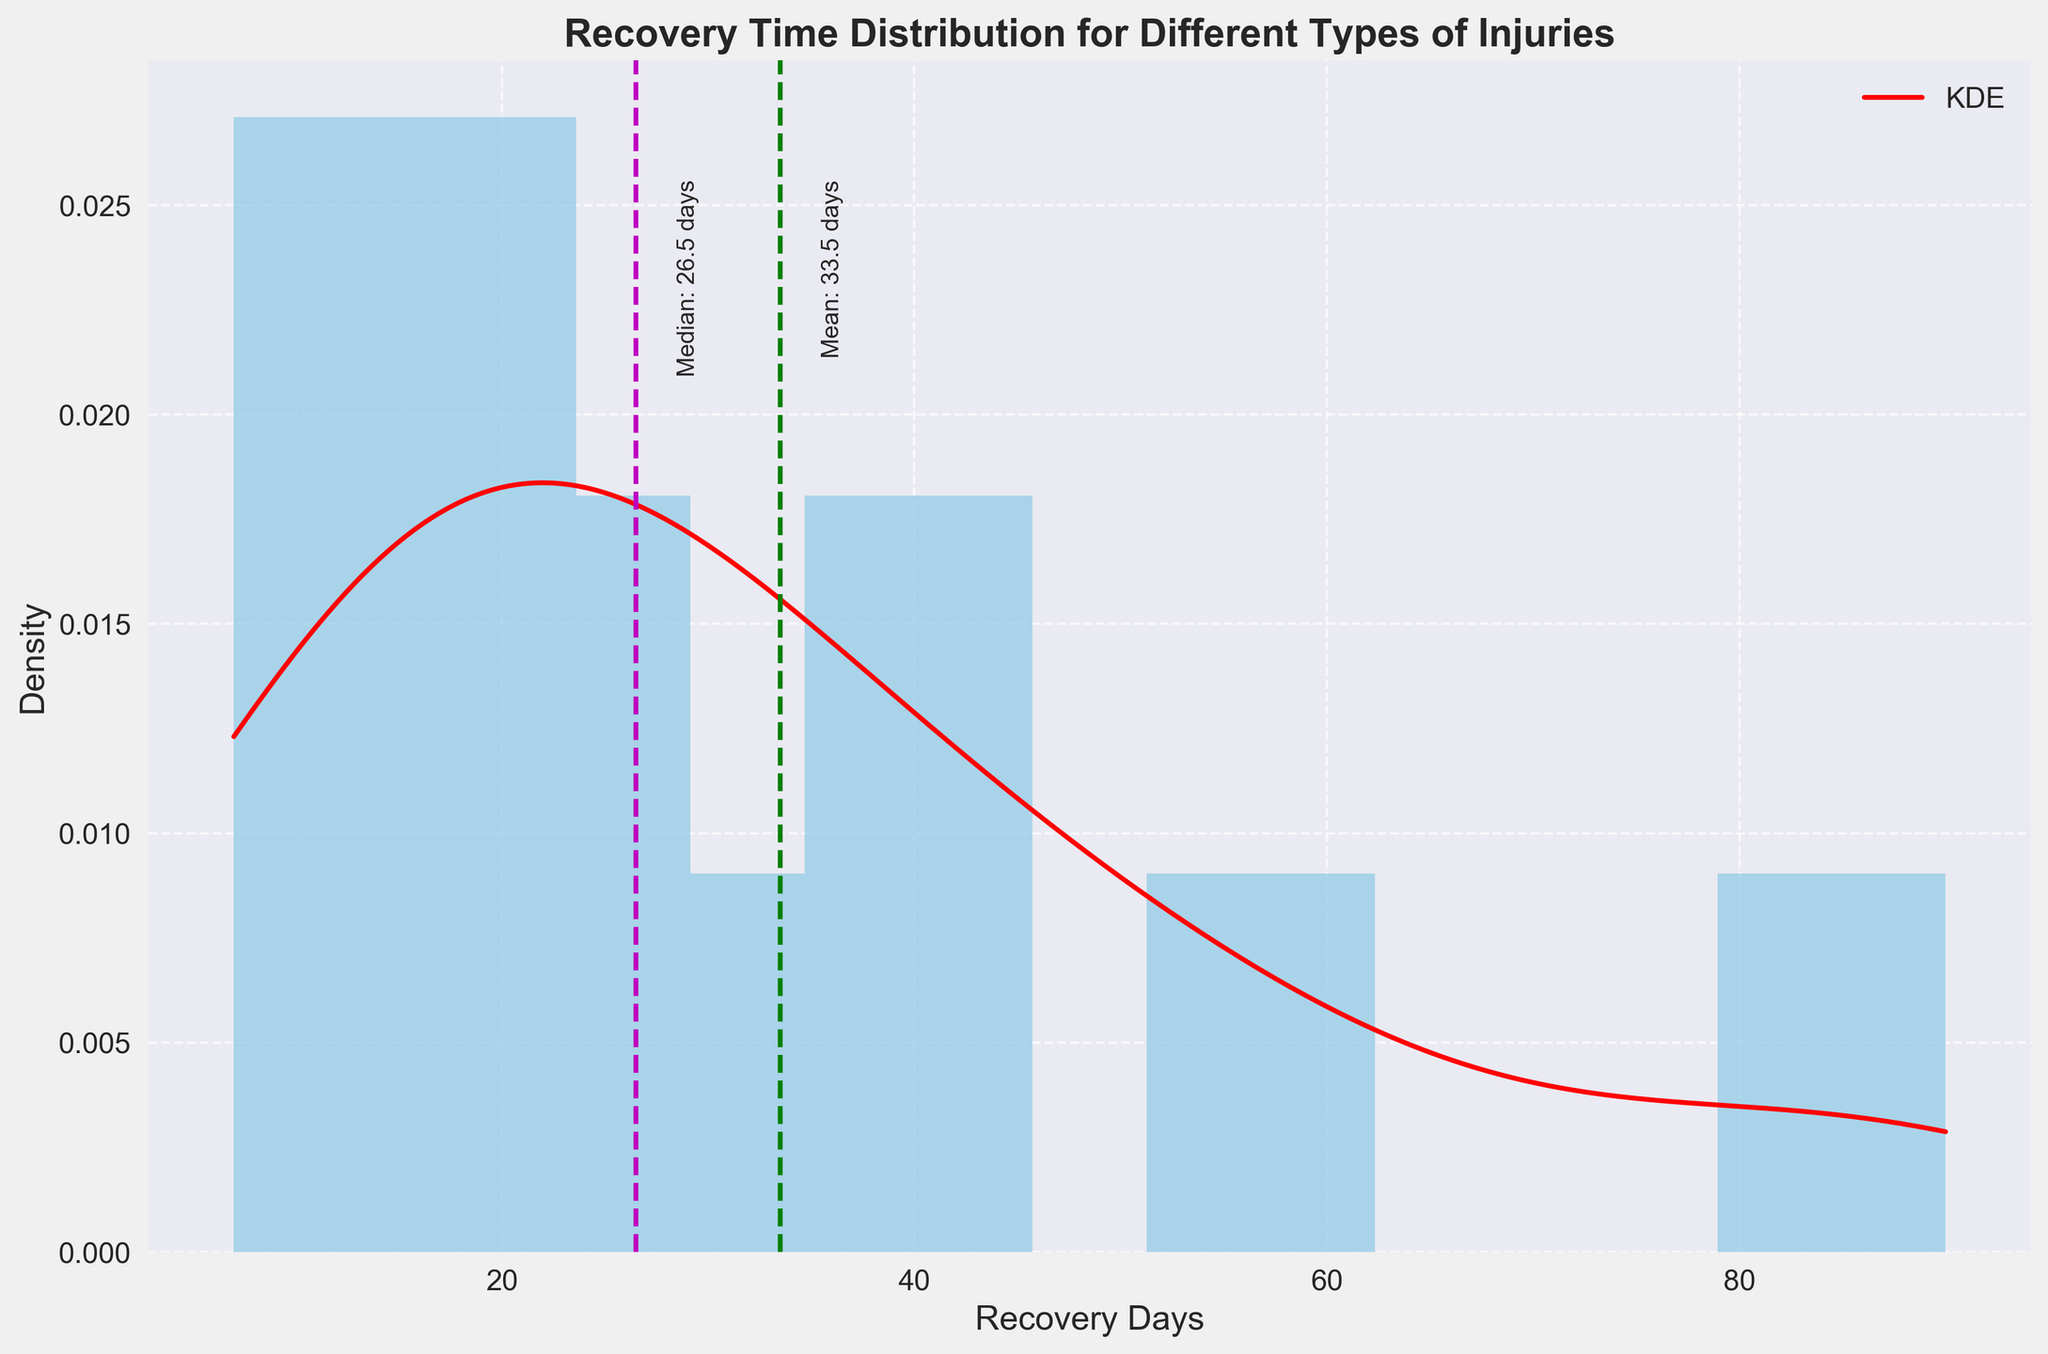How many different types of injuries are represented in the histogram? The histogram bins represent recovery days, while the types of injuries correspond to the data points aggregated under these bins. By counting the different categories in the data provided, we can identify 18 distinct injury types.
Answer: 18 What is the title of the plot? The title of the plot is displayed at the top of the figure. It reads, "Recovery Time Distribution for Different Types of Injuries".
Answer: Recovery Time Distribution for Different Types of Injuries What color represents the histogram bars? The color of the histogram bars can be identified visually. The bars are filled with a color that appears to be light blue.
Answer: Light blue What is the mean recovery time indicated by the green dashed line? The green dashed line is meant to indicate the mean recovery time. By looking for the green dashed vertical line and referring to the text next to it, the mean recovery time is around 36.9 days.
Answer: 36.9 days What is the median recovery time indicated by the magenta dashed line? The magenta dashed line indicates the median recovery time. By finding this vertical line and referring to the text next to it, the median recovery time is around 27.5 days.
Answer: 27.5 days What information is provided by the red curve plotted on the histogram? The red curve represents the KDE (Kernel Density Estimate), which shows the smoothed distribution of the recovery days, providing a continuous probability density function over the data points.
Answer: KDE Compare the mean and median recovery times. Which is higher? From the plot, identify the green dashed line for the mean and the magenta dashed line for the median. The mean recovery time (around 36.9 days) is higher than the median recovery time (around 27.5 days).
Answer: Mean Are there more data points with recovery times below or above 35 days? Reviewing the histogram, count the number of bars to the left (below) and right (above) of the 35-day marker. There are more bars and thus more injury types with recovery times below 35 days.
Answer: Below 35 days What is the general shape of the KDE curve? The KDE curve shows a general trend; it rises initially, peaks around a certain number of days, and then gradually decreases. This suggests a unimodal distribution where most recovery times are concentrated around the peak.
Answer: Unimodal What is the range of recovery days covered in the histogram? The horizontal axis of the histogram shows the range of recovery days. It starts from the minimum recovery day value (7 days) to the maximum recovery day value (90 days).
Answer: 7 to 90 days 